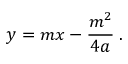Convert formula to latex. <formula><loc_0><loc_0><loc_500><loc_500>\ y = m x - { \frac { m ^ { 2 } } { 4 a } } \, .</formula> 